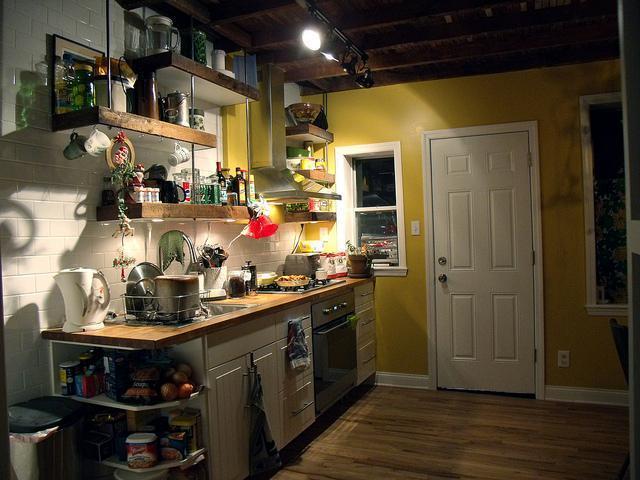How many people are not wearing goggles?
Give a very brief answer. 0. 